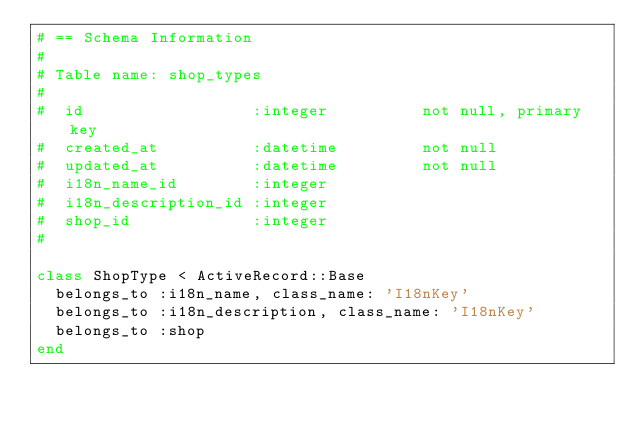Convert code to text. <code><loc_0><loc_0><loc_500><loc_500><_Ruby_># == Schema Information
#
# Table name: shop_types
#
#  id                  :integer          not null, primary key
#  created_at          :datetime         not null
#  updated_at          :datetime         not null
#  i18n_name_id        :integer
#  i18n_description_id :integer
#  shop_id             :integer
#

class ShopType < ActiveRecord::Base
  belongs_to :i18n_name, class_name: 'I18nKey'
  belongs_to :i18n_description, class_name: 'I18nKey'
  belongs_to :shop
end
</code> 